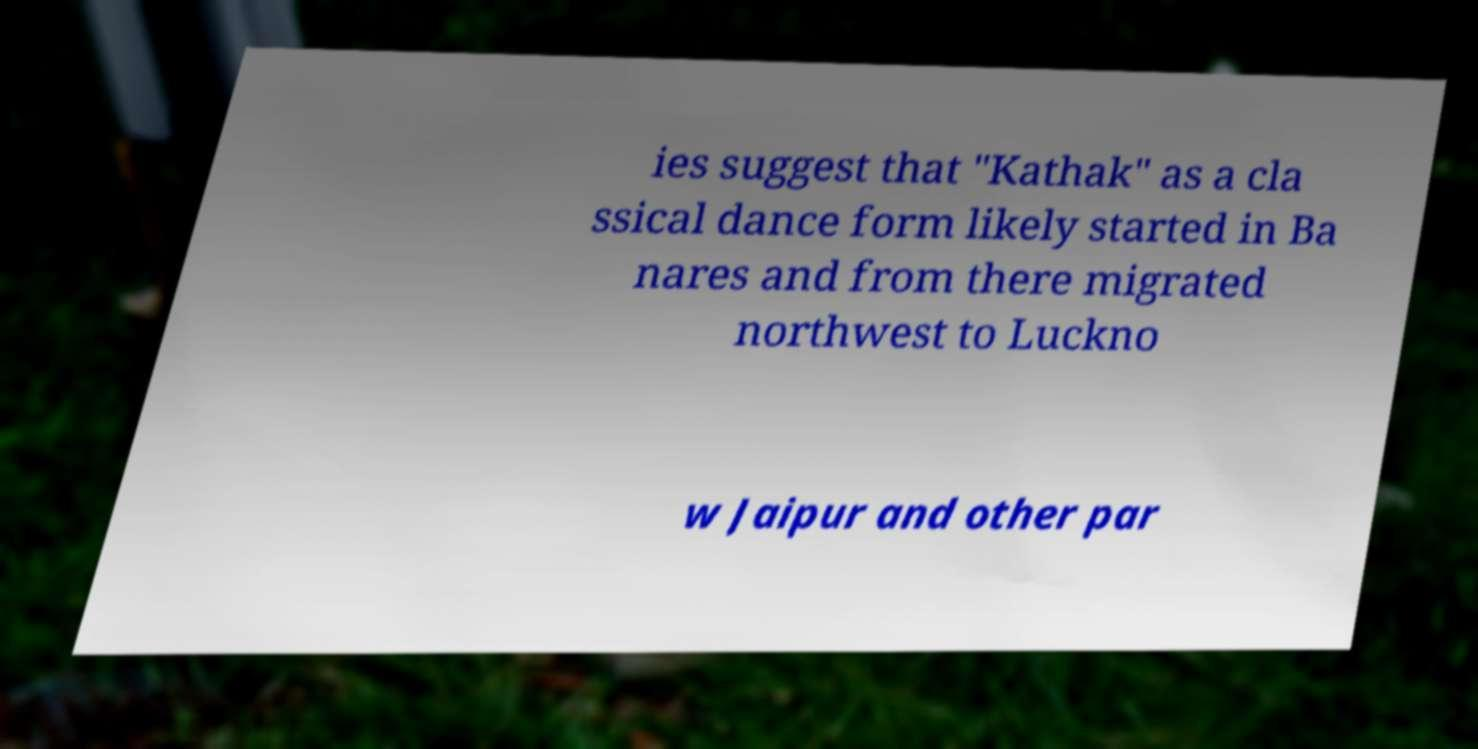Can you read and provide the text displayed in the image?This photo seems to have some interesting text. Can you extract and type it out for me? ies suggest that "Kathak" as a cla ssical dance form likely started in Ba nares and from there migrated northwest to Luckno w Jaipur and other par 